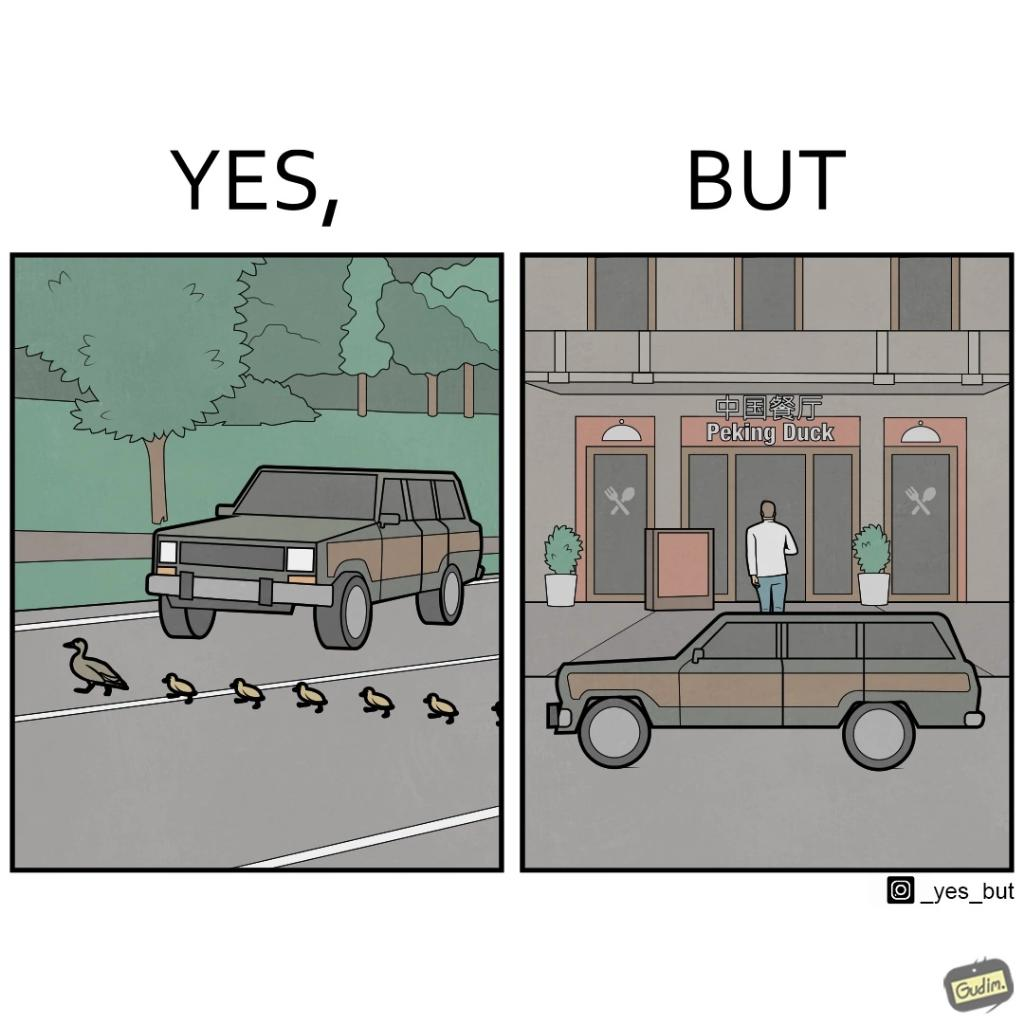Describe the contrast between the left and right parts of this image. In the left part of the image: It is a car stopping to give way to queue of ducks crossing the road and allow them to cross safely In the right part of the image: It is a man parking his car and entering a peking duck shop 